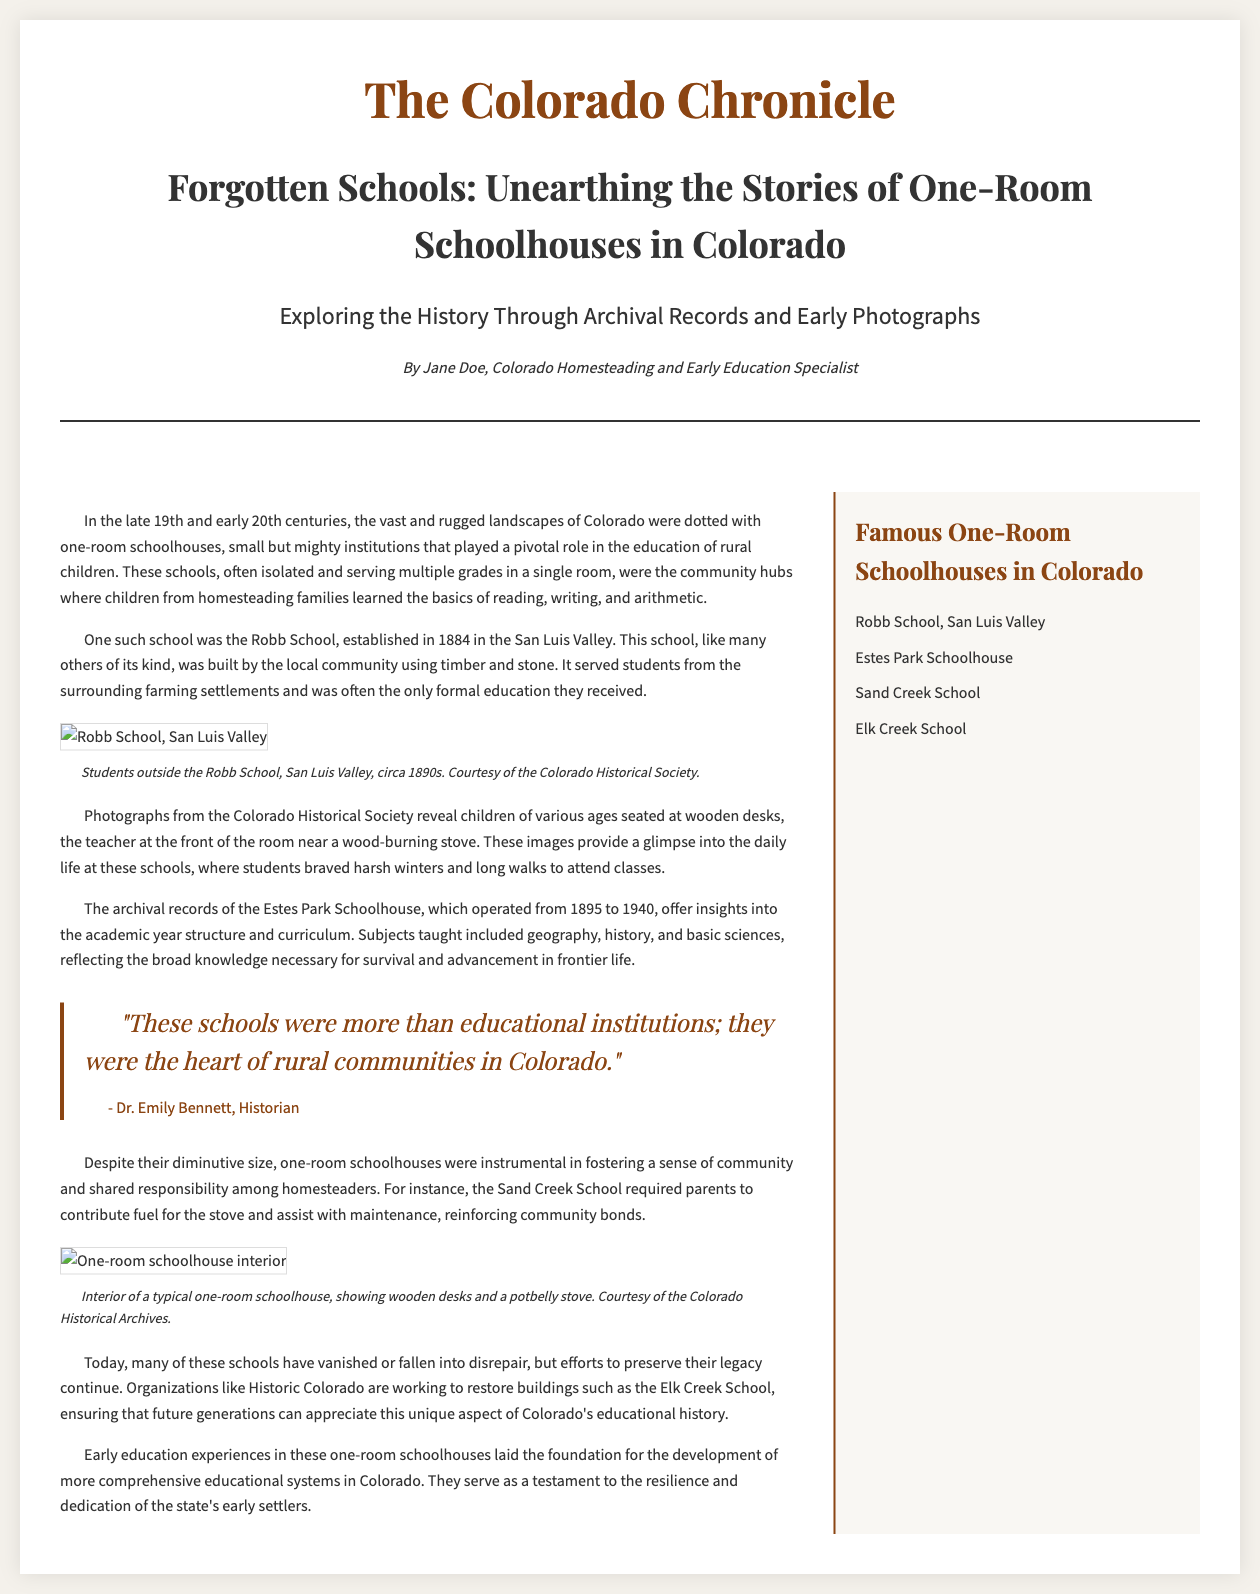What year was the Robb School established? The document states that the Robb School was established in 1884.
Answer: 1884 How long did the Estes Park Schoolhouse operate? The document states that the Estes Park Schoolhouse operated from 1895 to 1940, which is 45 years.
Answer: 45 years What did parents contribute for the Sand Creek School? The document mentions that parents were required to contribute fuel for the stove.
Answer: Fuel Who is the author of the article? The document lists Jane Doe as the author of the article.
Answer: Jane Doe What is the primary focus of the article? The document's headline indicates that the primary focus is on unearthing the stories of one-room schoolhouses in Colorado.
Answer: One-room schoolhouses What does the interior of one-room schoolhouses typically feature? The document describes the interior of a typical one-room schoolhouse as showing wooden desks and a potbelly stove.
Answer: Wooden desks and a potbelly stove Which organization is mentioned as working to restore school buildings? The document mentions Historic Colorado as an organization working to restore buildings.
Answer: Historic Colorado What was the role of one-room schoolhouses in rural communities? The document states that one-room schoolhouses were instrumental in fostering a sense of community and shared responsibility among homesteaders.
Answer: Fostering community What kind of photographs are used in the article? The document states that the article uses early photographs from the Colorado Historical Society.
Answer: Early photographs 